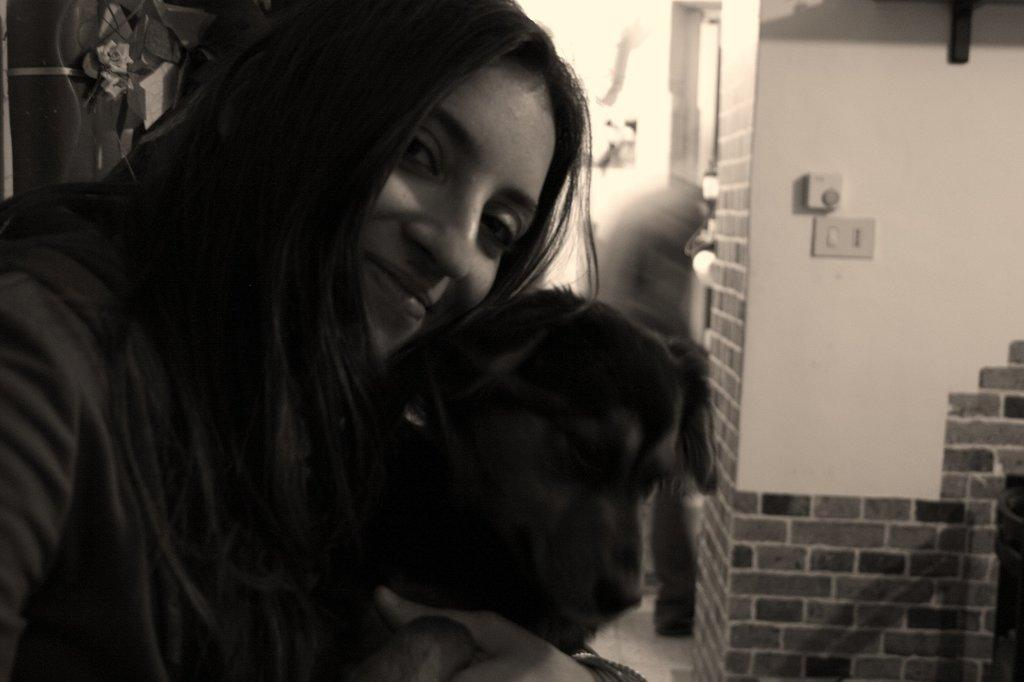What is the color scheme of the image? The image is black and white. Who is present in the image? There is a woman in the image. What is the woman holding in the image? The woman is holding a dog. What expression does the woman have in the image? The woman is smiling. What type of badge is the woman wearing in the image? There is no badge visible in the image. What is the woman's chin like in the image? There is no information about the woman's chin in the image. 